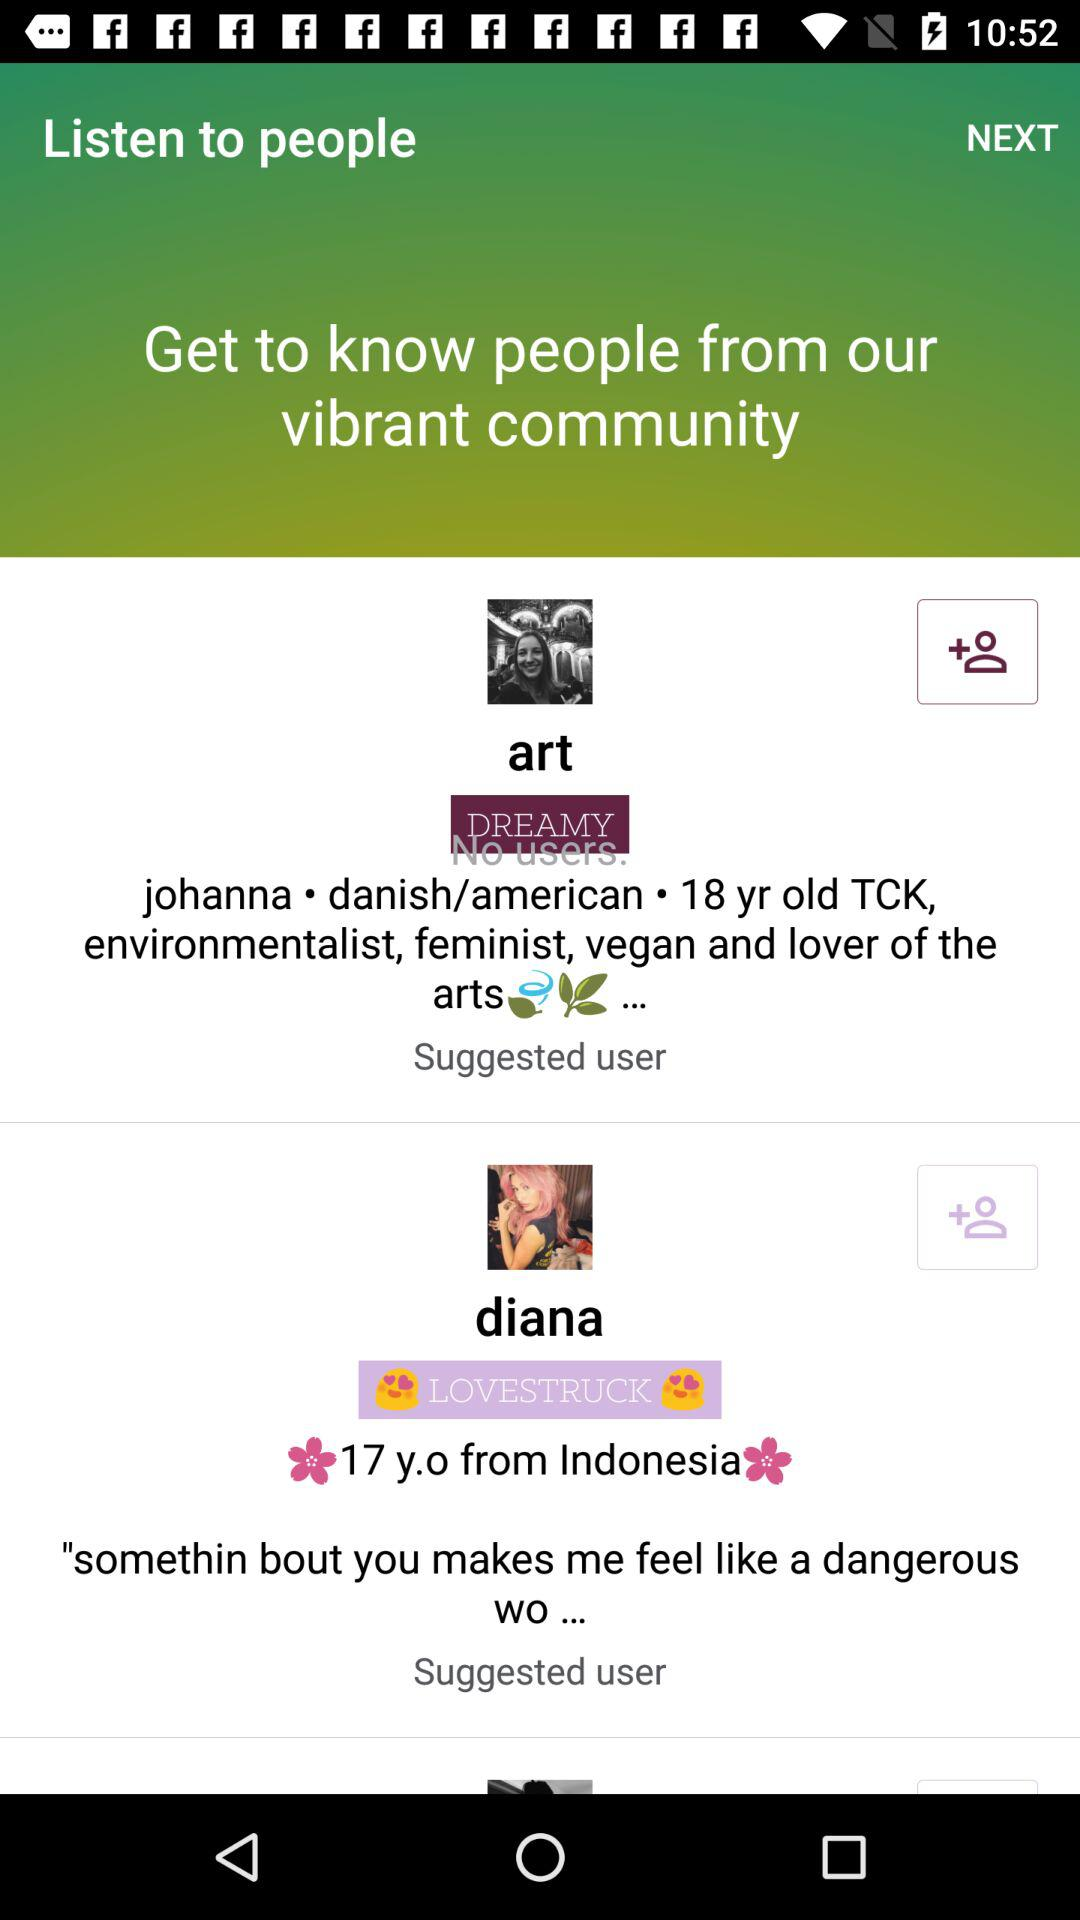How old is Johanna? Johanna is 18 years old. 